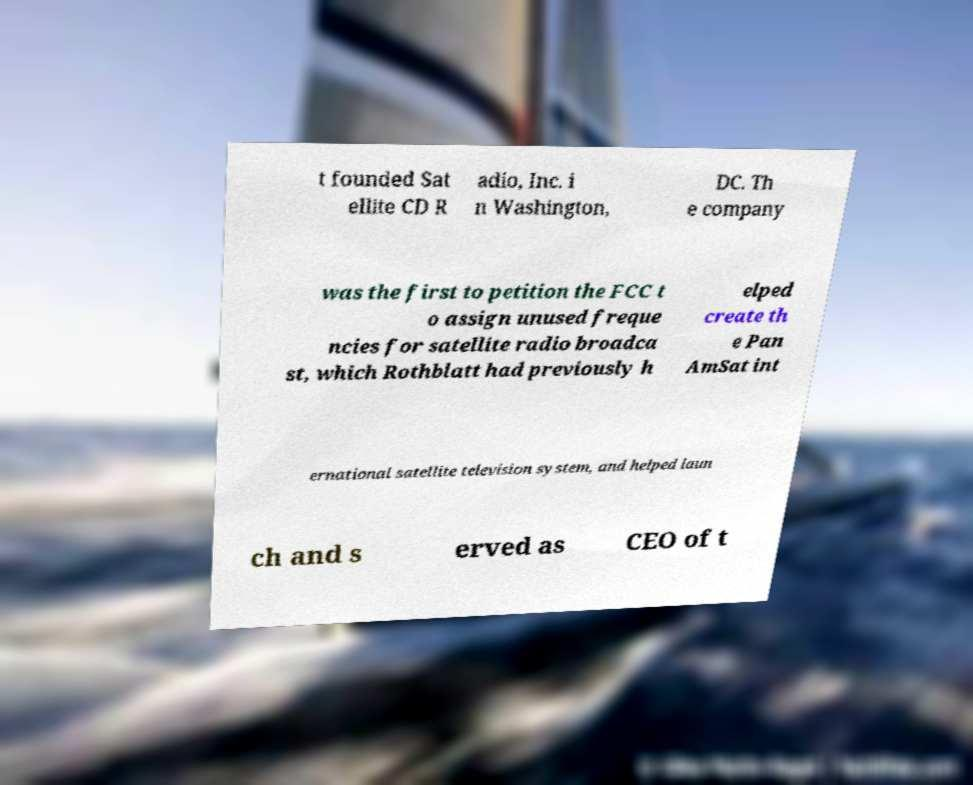Please read and relay the text visible in this image. What does it say? t founded Sat ellite CD R adio, Inc. i n Washington, DC. Th e company was the first to petition the FCC t o assign unused freque ncies for satellite radio broadca st, which Rothblatt had previously h elped create th e Pan AmSat int ernational satellite television system, and helped laun ch and s erved as CEO of t 